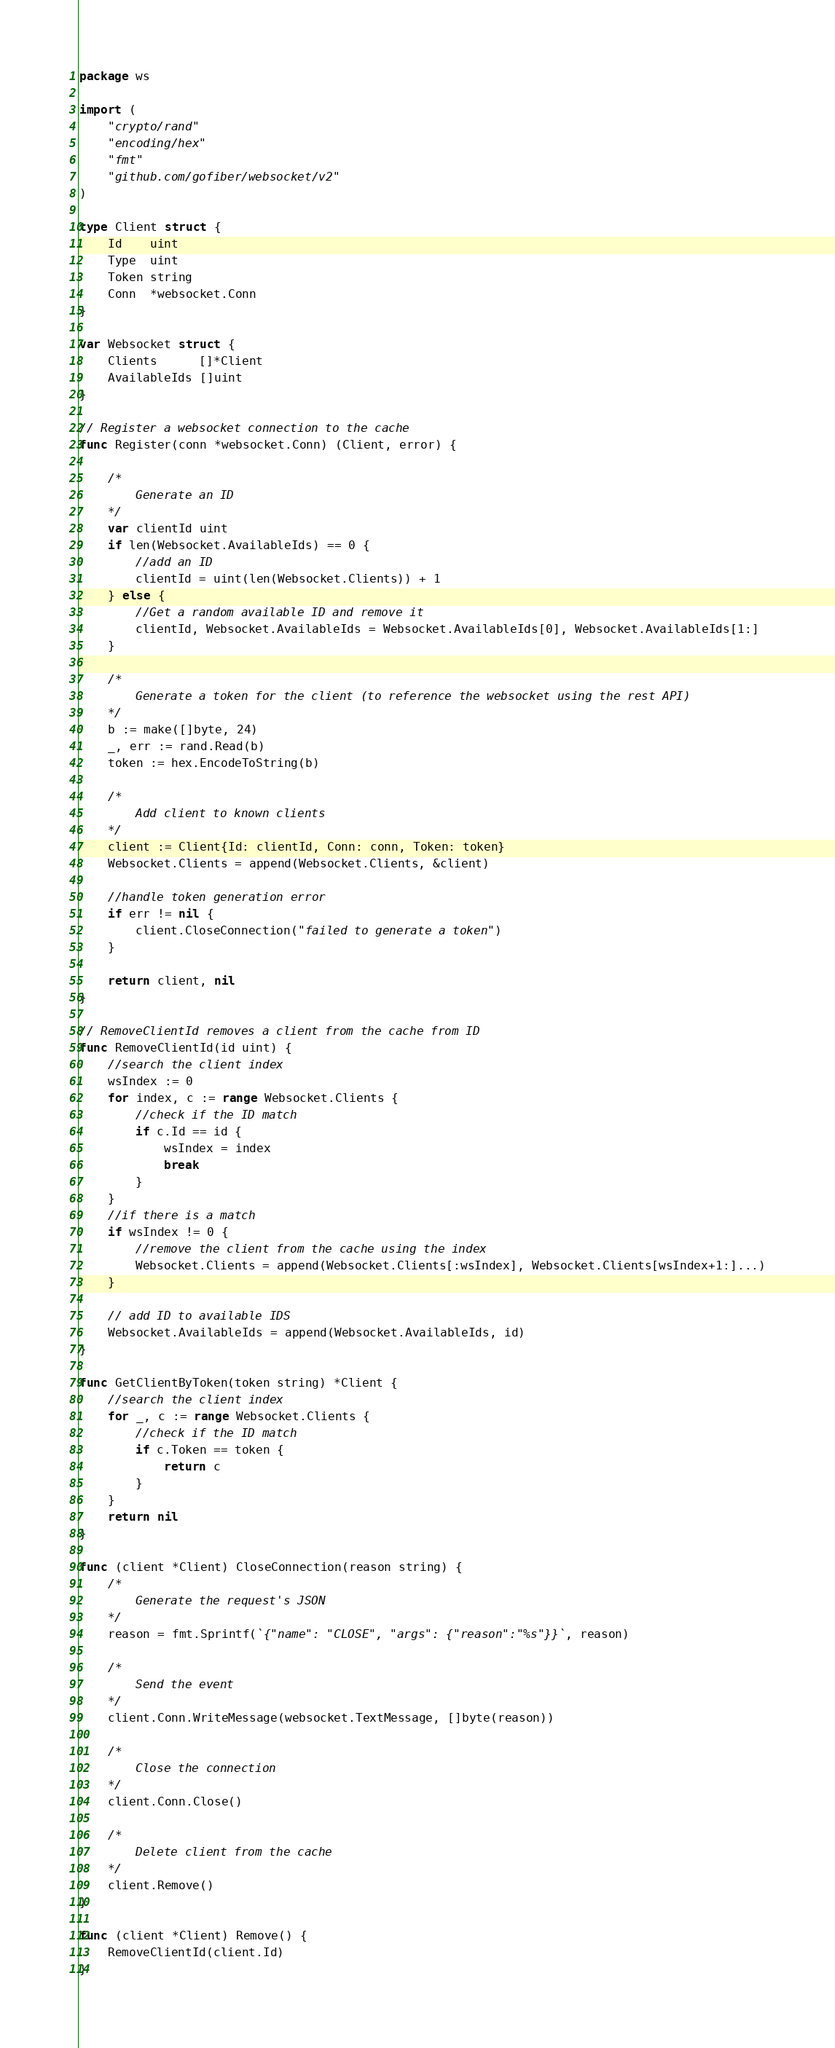<code> <loc_0><loc_0><loc_500><loc_500><_Go_>package ws

import (
	"crypto/rand"
	"encoding/hex"
	"fmt"
	"github.com/gofiber/websocket/v2"
)

type Client struct {
	Id    uint
	Type  uint
	Token string
	Conn  *websocket.Conn
}

var Websocket struct {
	Clients      []*Client
	AvailableIds []uint
}

// Register a websocket connection to the cache
func Register(conn *websocket.Conn) (Client, error) {

	/*
		Generate an ID
	*/
	var clientId uint
	if len(Websocket.AvailableIds) == 0 {
		//add an ID
		clientId = uint(len(Websocket.Clients)) + 1
	} else {
		//Get a random available ID and remove it
		clientId, Websocket.AvailableIds = Websocket.AvailableIds[0], Websocket.AvailableIds[1:]
	}

	/*
		Generate a token for the client (to reference the websocket using the rest API)
	*/
	b := make([]byte, 24)
	_, err := rand.Read(b)
	token := hex.EncodeToString(b)

	/*
		Add client to known clients
	*/
	client := Client{Id: clientId, Conn: conn, Token: token}
	Websocket.Clients = append(Websocket.Clients, &client)

	//handle token generation error
	if err != nil {
		client.CloseConnection("failed to generate a token")
	}

	return client, nil
}

// RemoveClientId removes a client from the cache from ID
func RemoveClientId(id uint) {
	//search the client index
	wsIndex := 0
	for index, c := range Websocket.Clients {
		//check if the ID match
		if c.Id == id {
			wsIndex = index
			break
		}
	}
	//if there is a match
	if wsIndex != 0 {
		//remove the client from the cache using the index
		Websocket.Clients = append(Websocket.Clients[:wsIndex], Websocket.Clients[wsIndex+1:]...)
	}

	// add ID to available IDS
	Websocket.AvailableIds = append(Websocket.AvailableIds, id)
}

func GetClientByToken(token string) *Client {
	//search the client index
	for _, c := range Websocket.Clients {
		//check if the ID match
		if c.Token == token {
			return c
		}
	}
	return nil
}

func (client *Client) CloseConnection(reason string) {
	/*
		Generate the request's JSON
	*/
	reason = fmt.Sprintf(`{"name": "CLOSE", "args": {"reason":"%s"}}`, reason)

	/*
		Send the event
	*/
	client.Conn.WriteMessage(websocket.TextMessage, []byte(reason))

	/*
		Close the connection
	*/
	client.Conn.Close()

	/*
		Delete client from the cache
	*/
	client.Remove()
}

func (client *Client) Remove() {
	RemoveClientId(client.Id)
}
</code> 